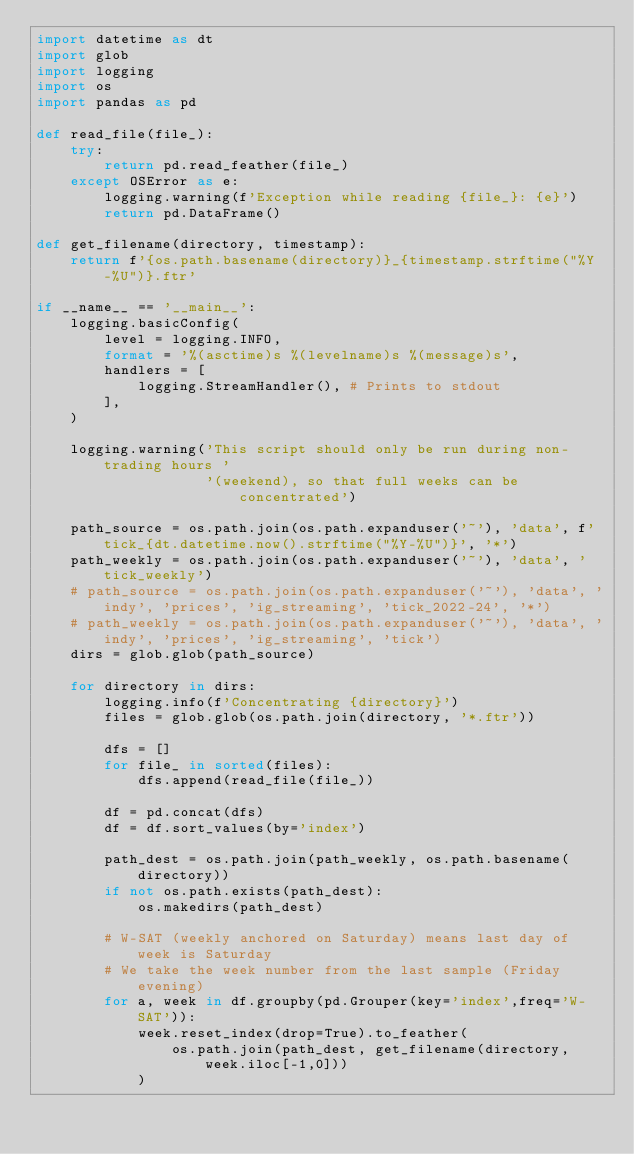Convert code to text. <code><loc_0><loc_0><loc_500><loc_500><_Python_>import datetime as dt
import glob
import logging
import os
import pandas as pd

def read_file(file_):
    try:
        return pd.read_feather(file_)
    except OSError as e:
        logging.warning(f'Exception while reading {file_}: {e}')
        return pd.DataFrame()

def get_filename(directory, timestamp):
    return f'{os.path.basename(directory)}_{timestamp.strftime("%Y-%U")}.ftr'

if __name__ == '__main__':
    logging.basicConfig(
        level = logging.INFO,
        format = '%(asctime)s %(levelname)s %(message)s',
        handlers = [
            logging.StreamHandler(), # Prints to stdout
        ],
    )

    logging.warning('This script should only be run during non-trading hours '
                    '(weekend), so that full weeks can be concentrated')

    path_source = os.path.join(os.path.expanduser('~'), 'data', f'tick_{dt.datetime.now().strftime("%Y-%U")}', '*')
    path_weekly = os.path.join(os.path.expanduser('~'), 'data', 'tick_weekly')
    # path_source = os.path.join(os.path.expanduser('~'), 'data', 'indy', 'prices', 'ig_streaming', 'tick_2022-24', '*')
    # path_weekly = os.path.join(os.path.expanduser('~'), 'data', 'indy', 'prices', 'ig_streaming', 'tick')
    dirs = glob.glob(path_source)

    for directory in dirs:
        logging.info(f'Concentrating {directory}')
        files = glob.glob(os.path.join(directory, '*.ftr'))

        dfs = []
        for file_ in sorted(files):
            dfs.append(read_file(file_))

        df = pd.concat(dfs)
        df = df.sort_values(by='index')

        path_dest = os.path.join(path_weekly, os.path.basename(directory))
        if not os.path.exists(path_dest):
            os.makedirs(path_dest)
        
        # W-SAT (weekly anchored on Saturday) means last day of week is Saturday
        # We take the week number from the last sample (Friday evening)
        for a, week in df.groupby(pd.Grouper(key='index',freq='W-SAT')):
            week.reset_index(drop=True).to_feather(
                os.path.join(path_dest, get_filename(directory, week.iloc[-1,0]))
            )</code> 